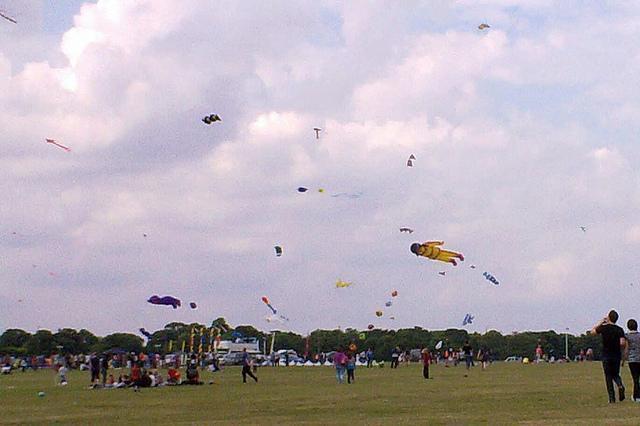What is the largest kite flying made to resemble?
Answer the question by selecting the correct answer among the 4 following choices and explain your choice with a short sentence. The answer should be formatted with the following format: `Answer: choice
Rationale: rationale.`
Options: Moth, cell phone, hummingbird, human. Answer: human.
Rationale: The yellow kite is the largest. it resembles a human. 